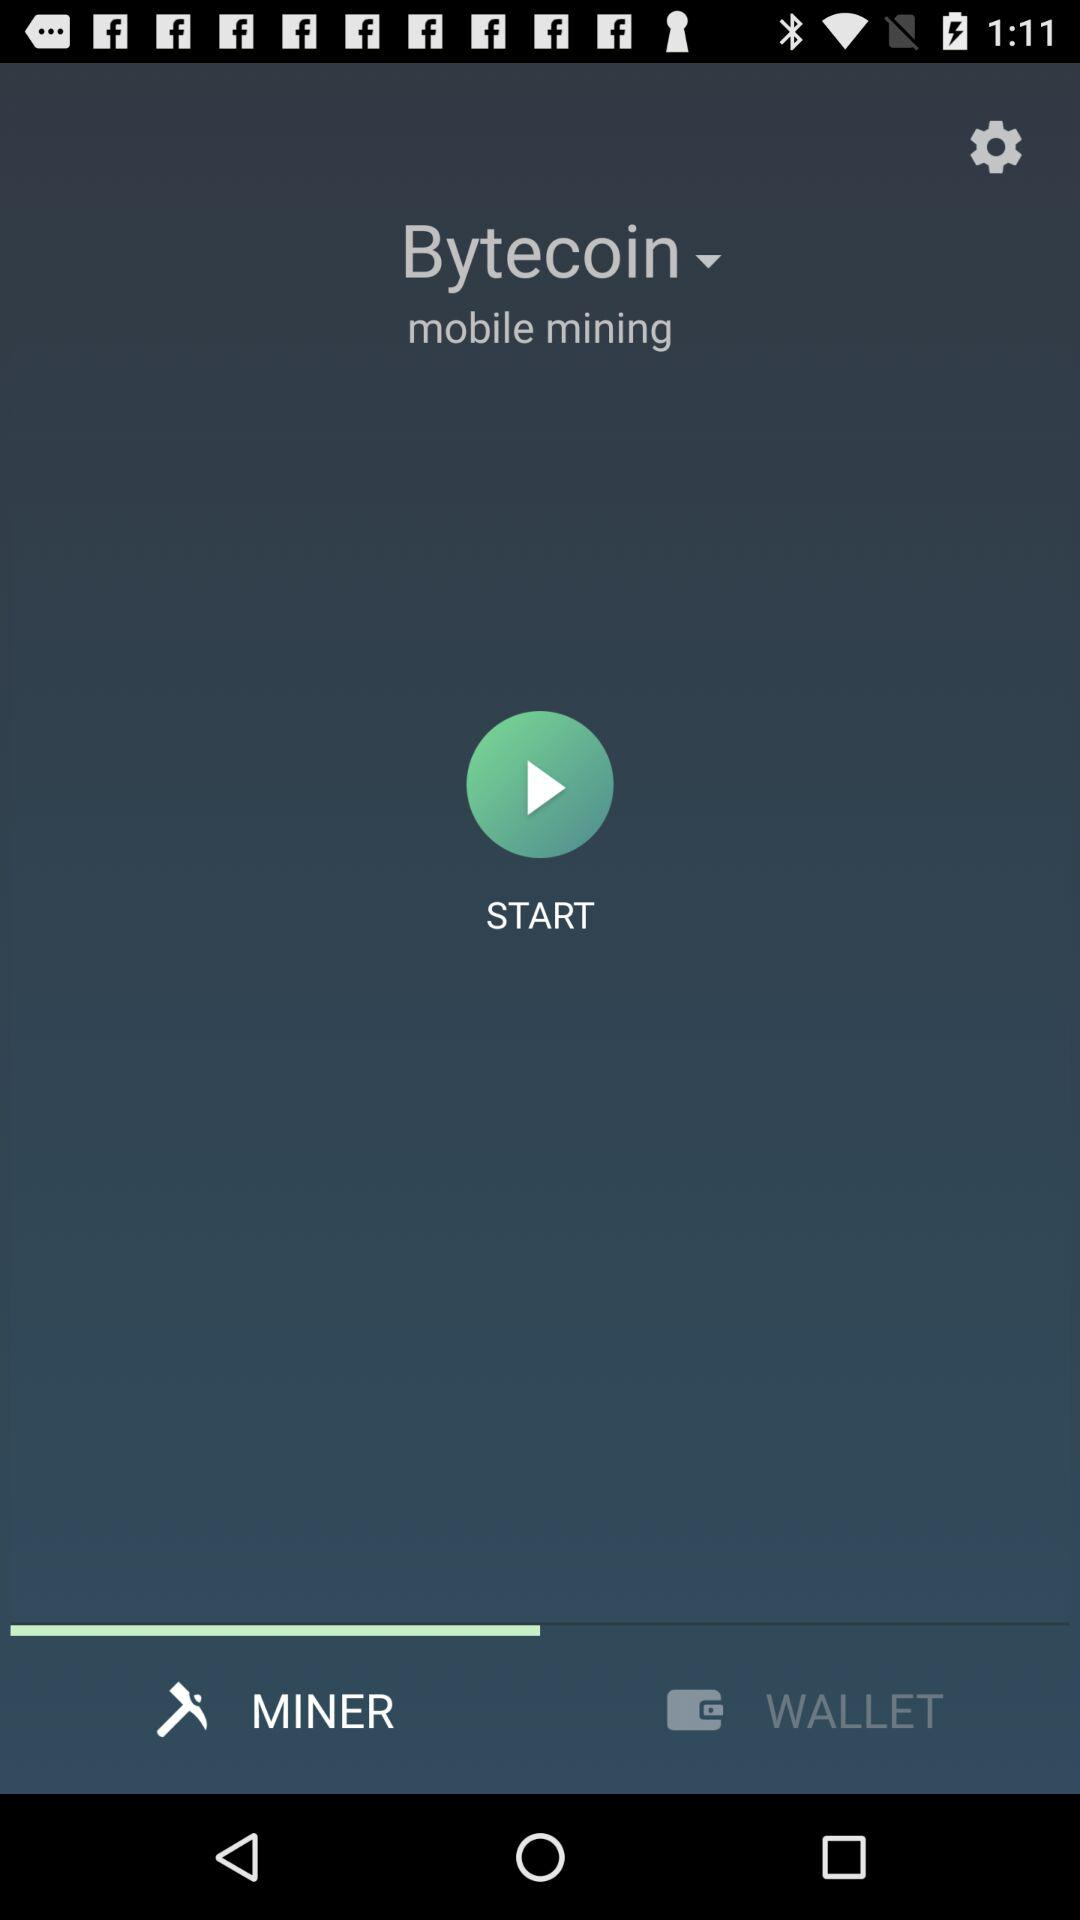Which tab is selected? The selected tab is "MIner". 